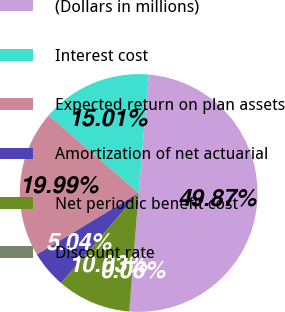Convert chart to OTSL. <chart><loc_0><loc_0><loc_500><loc_500><pie_chart><fcel>(Dollars in millions)<fcel>Interest cost<fcel>Expected return on plan assets<fcel>Amortization of net actuarial<fcel>Net periodic benefit cost<fcel>Discount rate<nl><fcel>49.87%<fcel>15.01%<fcel>19.99%<fcel>5.04%<fcel>10.03%<fcel>0.06%<nl></chart> 